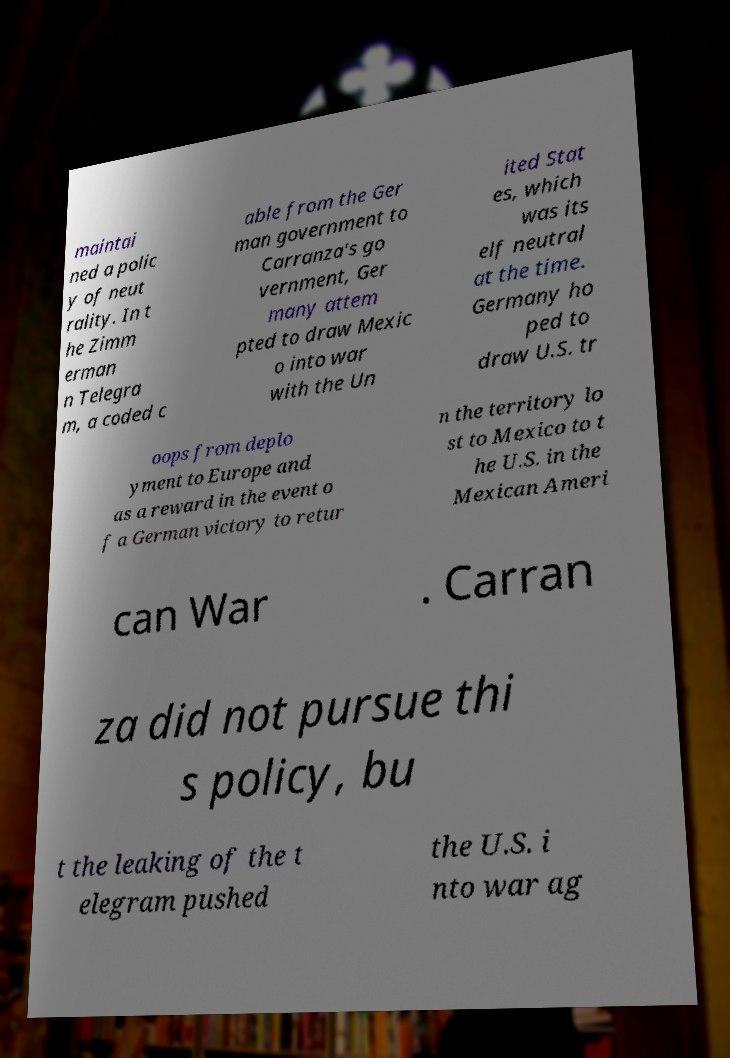Could you extract and type out the text from this image? maintai ned a polic y of neut rality. In t he Zimm erman n Telegra m, a coded c able from the Ger man government to Carranza's go vernment, Ger many attem pted to draw Mexic o into war with the Un ited Stat es, which was its elf neutral at the time. Germany ho ped to draw U.S. tr oops from deplo yment to Europe and as a reward in the event o f a German victory to retur n the territory lo st to Mexico to t he U.S. in the Mexican Ameri can War . Carran za did not pursue thi s policy, bu t the leaking of the t elegram pushed the U.S. i nto war ag 